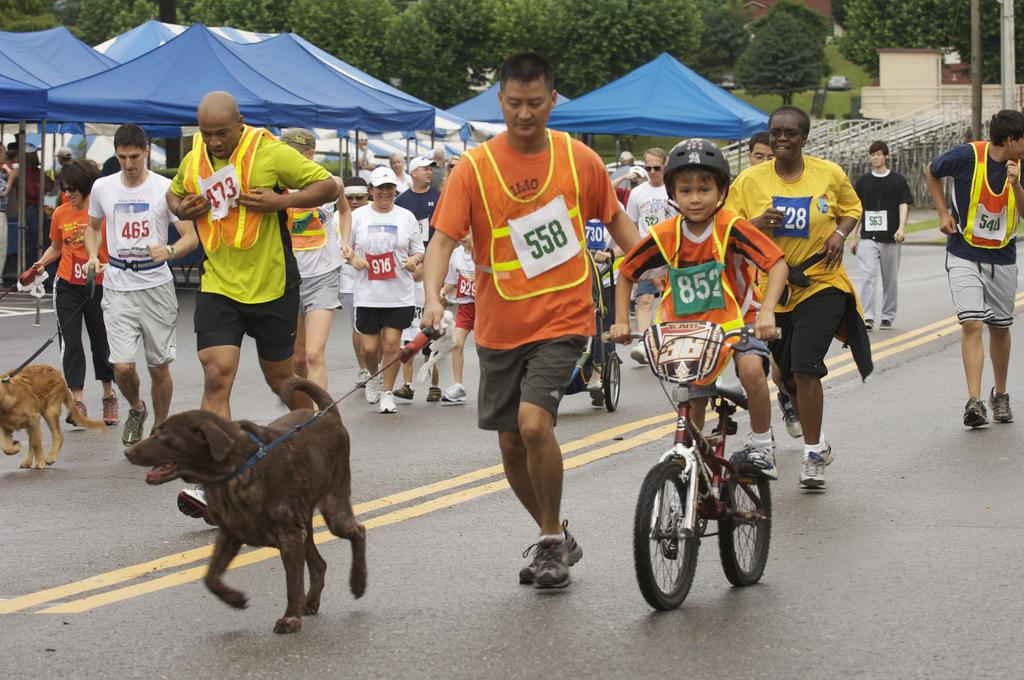What are the persons in the image doing? The persons in the image are running on the road. What mode of transportation is being used by one of the persons in the image? There is a person on a bicycle in the image. What animals can be seen in the image? Dogs are present in the image. What objects might be used for protection from the rain in the image? Umbrellas are present in the image. What type of vegetation is visible in the image? There are trees in the image. What type of structure is visible in the image? There is a house in the image. What type of vertical structure is visible in the image? There is a pole in the image. What is the title of the book being read by the person on the bicycle in the image? There is no book or person reading in the image. What type of rhythm can be heard from the dogs in the image? There are no sounds or rhythm associated with the dogs in the image. 